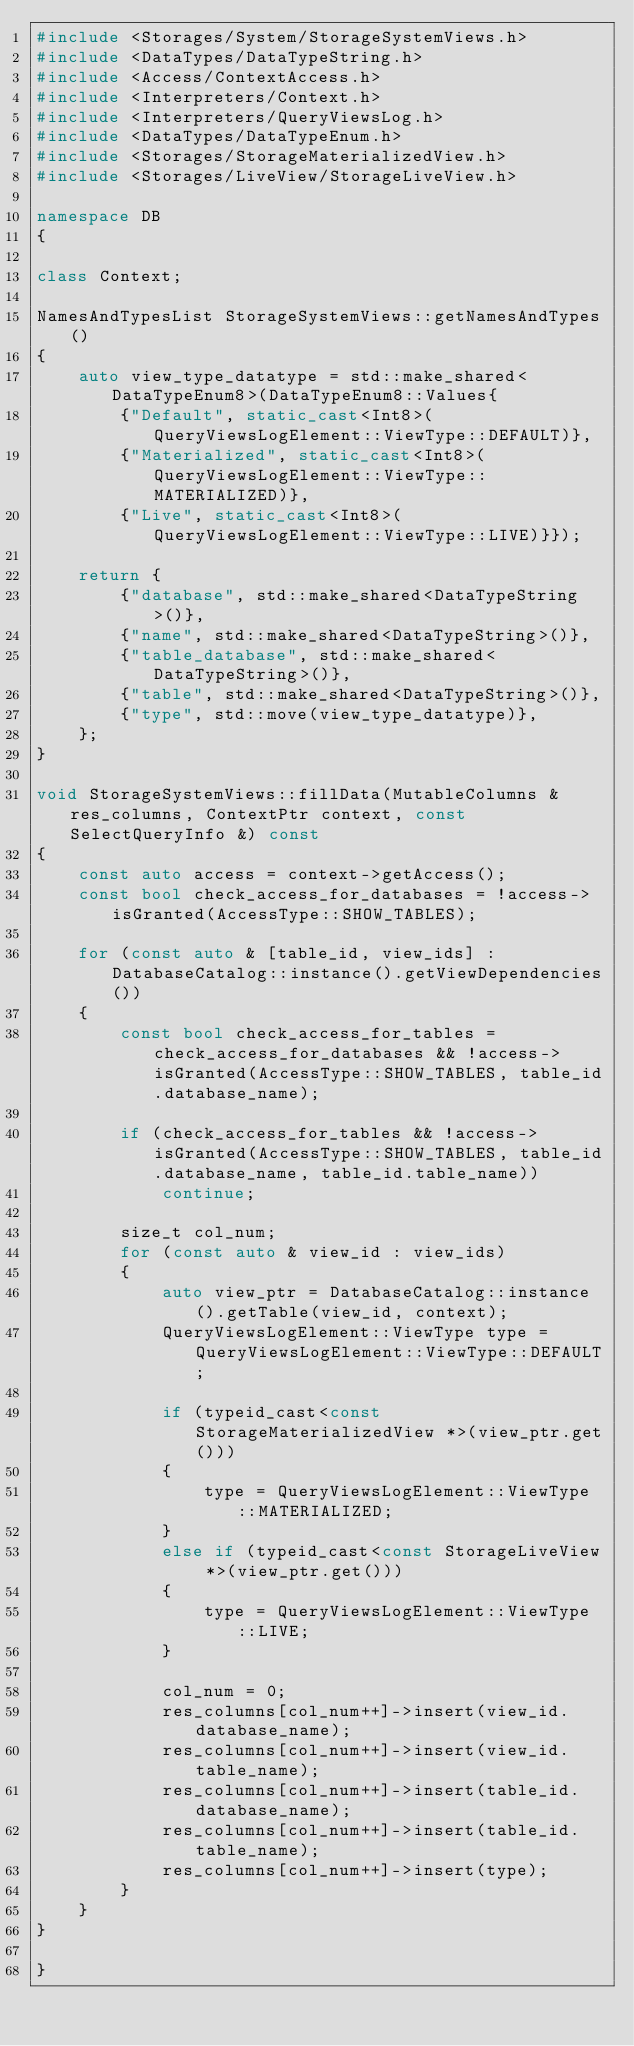<code> <loc_0><loc_0><loc_500><loc_500><_C++_>#include <Storages/System/StorageSystemViews.h>
#include <DataTypes/DataTypeString.h>
#include <Access/ContextAccess.h>
#include <Interpreters/Context.h>
#include <Interpreters/QueryViewsLog.h>
#include <DataTypes/DataTypeEnum.h>
#include <Storages/StorageMaterializedView.h>
#include <Storages/LiveView/StorageLiveView.h>

namespace DB
{

class Context;

NamesAndTypesList StorageSystemViews::getNamesAndTypes()
{
    auto view_type_datatype = std::make_shared<DataTypeEnum8>(DataTypeEnum8::Values{
        {"Default", static_cast<Int8>(QueryViewsLogElement::ViewType::DEFAULT)},
        {"Materialized", static_cast<Int8>(QueryViewsLogElement::ViewType::MATERIALIZED)},
        {"Live", static_cast<Int8>(QueryViewsLogElement::ViewType::LIVE)}});

    return {
        {"database", std::make_shared<DataTypeString>()},
        {"name", std::make_shared<DataTypeString>()},
        {"table_database", std::make_shared<DataTypeString>()},
        {"table", std::make_shared<DataTypeString>()},
        {"type", std::move(view_type_datatype)},
    };
}

void StorageSystemViews::fillData(MutableColumns & res_columns, ContextPtr context, const SelectQueryInfo &) const
{
    const auto access = context->getAccess();
    const bool check_access_for_databases = !access->isGranted(AccessType::SHOW_TABLES);

    for (const auto & [table_id, view_ids] : DatabaseCatalog::instance().getViewDependencies())
    {
        const bool check_access_for_tables = check_access_for_databases && !access->isGranted(AccessType::SHOW_TABLES, table_id.database_name);

        if (check_access_for_tables && !access->isGranted(AccessType::SHOW_TABLES, table_id.database_name, table_id.table_name))
            continue;

        size_t col_num;
        for (const auto & view_id : view_ids)
        {
            auto view_ptr = DatabaseCatalog::instance().getTable(view_id, context);
            QueryViewsLogElement::ViewType type = QueryViewsLogElement::ViewType::DEFAULT;

            if (typeid_cast<const StorageMaterializedView *>(view_ptr.get()))
            {
                type = QueryViewsLogElement::ViewType::MATERIALIZED;
            }
            else if (typeid_cast<const StorageLiveView *>(view_ptr.get()))
            {
                type = QueryViewsLogElement::ViewType::LIVE;
            }

            col_num = 0;
            res_columns[col_num++]->insert(view_id.database_name);
            res_columns[col_num++]->insert(view_id.table_name);
            res_columns[col_num++]->insert(table_id.database_name);
            res_columns[col_num++]->insert(table_id.table_name);
            res_columns[col_num++]->insert(type);
        }
    }
}

}
</code> 